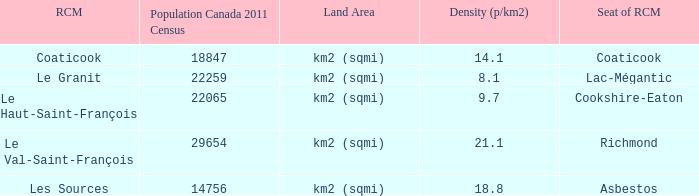What is the land area for the RCM that has a population of 18847? Km2 (sqmi). 